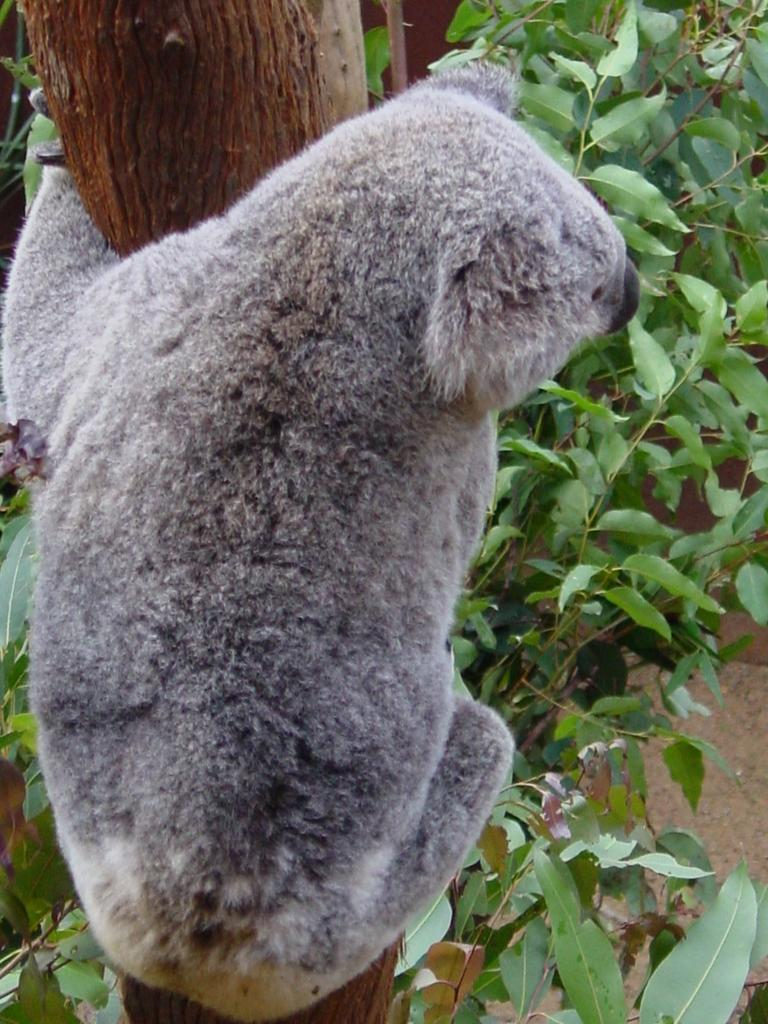What type of animal is on the tree in the image? There is a koala on a tree in the image. What is the koala sitting on in the image? The koala is sitting on a tree in the image. What can be seen in the background of the image? There are branches of a tree with leaves visible in the background. Can you tell me how many people are talking in the stocking at the cemetery in the image? There is no stocking, people, or cemetery present in the image; it features a koala on a tree. 